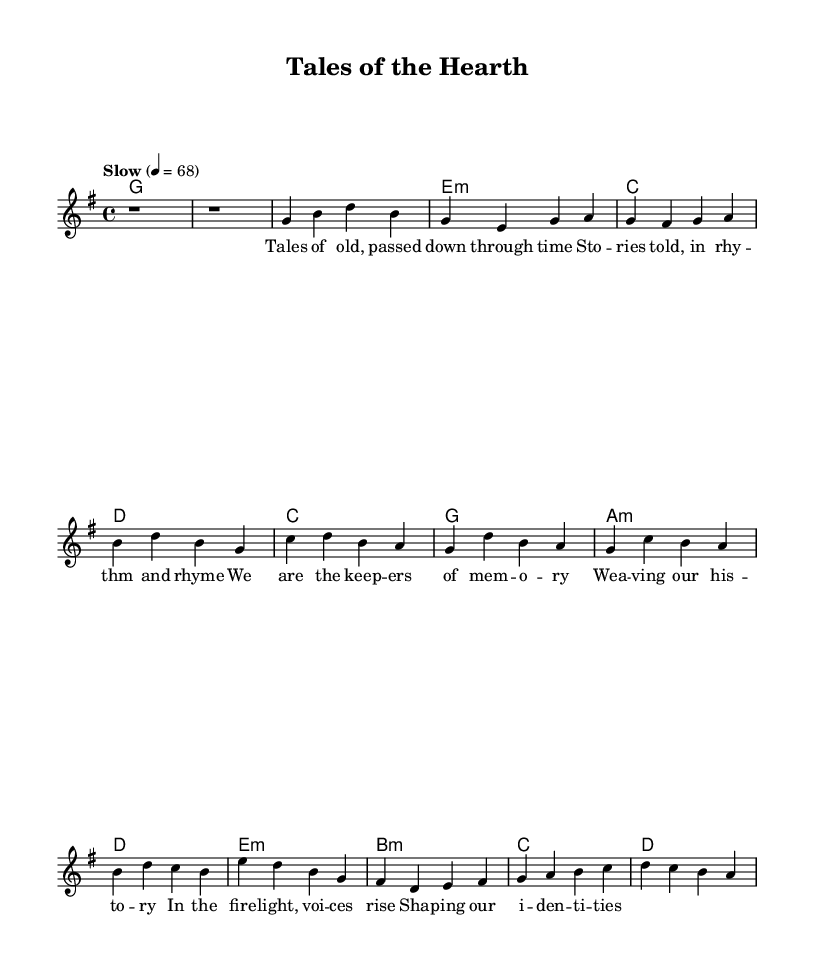What is the key signature of this music? The key signature is G major, characterized by one sharp (F#). This can be determined by looking at the global settings at the top of the sheet music where it specifies the key.
Answer: G major What is the time signature of this score? The time signature is 4/4, which can be observed in the global section of the sheet music. The fraction indicates that there are four beats in a measure and the quarter note gets one beat.
Answer: 4/4 What is the tempo marking for this piece? The tempo marking is 'Slow', indicated next to the tempo directive that sets the quarter note at 68 beats per minute. This provides a clear description of the desired speed for the performance.
Answer: Slow How many verses are there in the lyrics? There are two verses in the lyrics: one is labeled 'Verse 1' and includes the first set of lyrics, while the 'Chorus' acts as a secondary section between parts of the song. Thus, the primary lyrics are part of one full verse.
Answer: 2 What chords are used in the chorus? The chords in the chorus are C, G, A minor, and D. Each chord corresponds to a measure in the chorus section, which can be verified by examining the 'harmonies' part of the sheet music that aligns with the lyrical structure.
Answer: C, G, A minor, D What is the theme of the song as suggested by the lyrics? The theme centers on storytelling and preservation of memory, as reflected in the titles of the verses and the imagery depicted in the lyrics about voices rising and shaping identities around the firelight. This thematic focus is common in introspective country ballads.
Answer: Storytelling and memory 